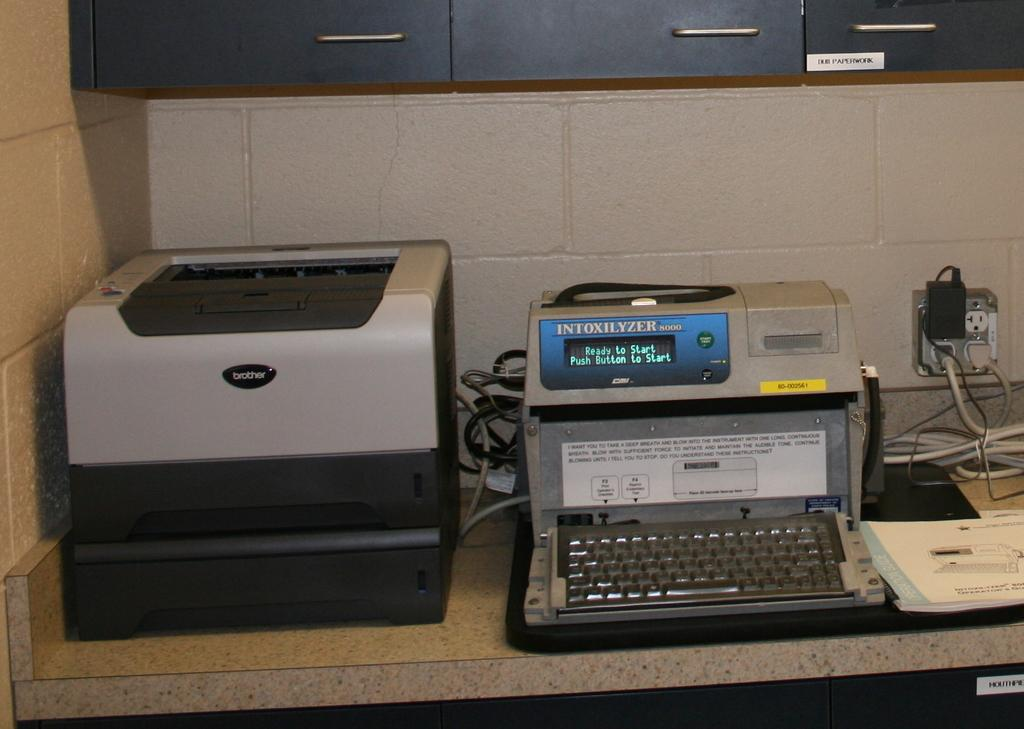What type of office equipment can be seen in the image? There is a printer and a typewriter in the image. Where are the printer and typewriter located? Both the printer and typewriter are placed on a desk in the image. What other objects can be seen in the image? There is an electric shaft, cables, and a book in the image. How does the payment system work in the image? There is no payment system present in the image; it features a printer, typewriter, desk, electric shaft, cables, and a book. 